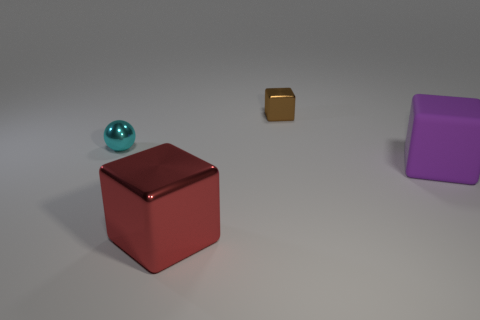Subtract all tiny metal blocks. How many blocks are left? 2 Add 2 large objects. How many objects exist? 6 Subtract all spheres. How many objects are left? 3 Subtract all red blocks. How many blocks are left? 2 Subtract all big purple balls. Subtract all big red metal objects. How many objects are left? 3 Add 3 tiny spheres. How many tiny spheres are left? 4 Add 4 yellow shiny spheres. How many yellow shiny spheres exist? 4 Subtract 0 blue cylinders. How many objects are left? 4 Subtract 3 cubes. How many cubes are left? 0 Subtract all brown cubes. Subtract all blue cylinders. How many cubes are left? 2 